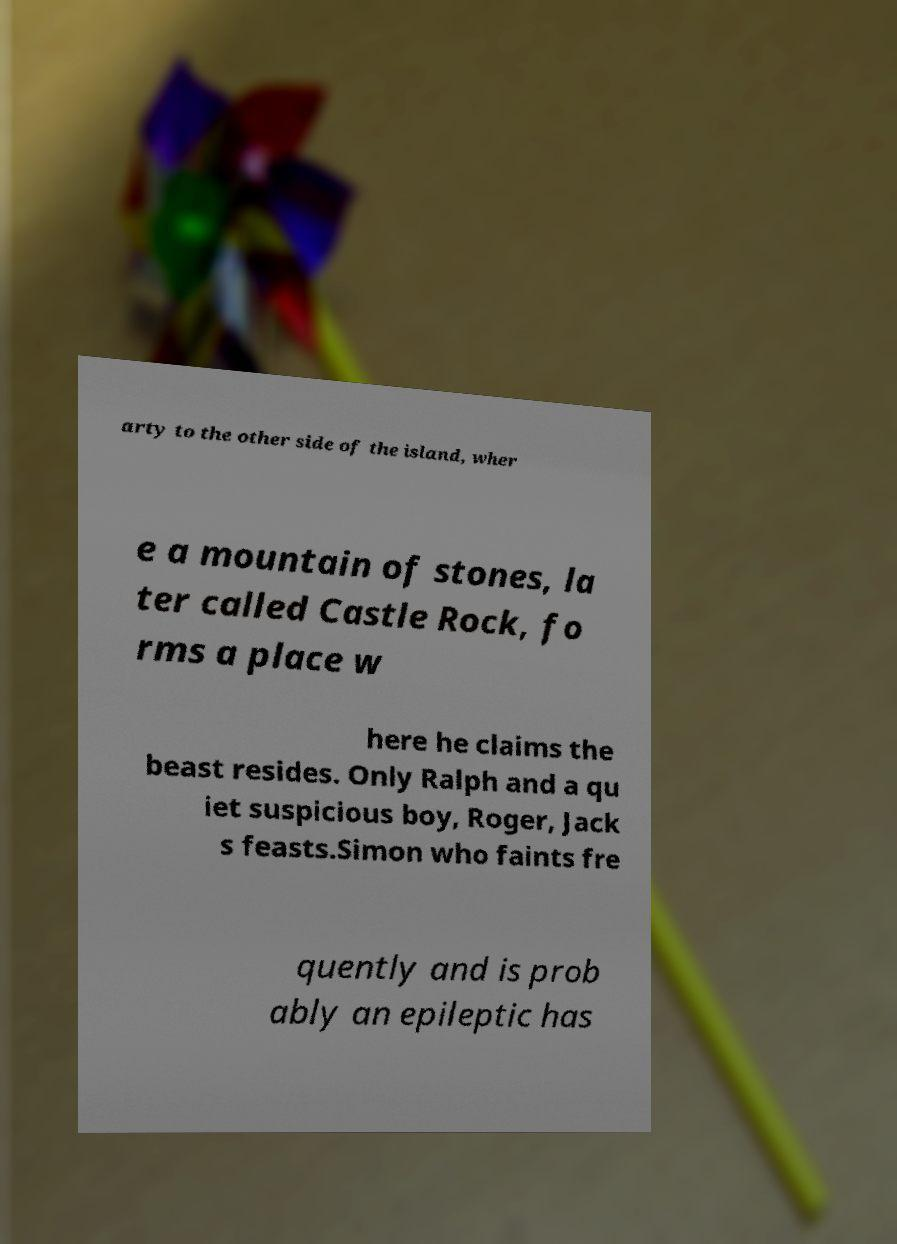Please identify and transcribe the text found in this image. arty to the other side of the island, wher e a mountain of stones, la ter called Castle Rock, fo rms a place w here he claims the beast resides. Only Ralph and a qu iet suspicious boy, Roger, Jack s feasts.Simon who faints fre quently and is prob ably an epileptic has 